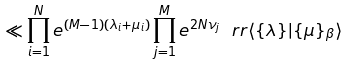<formula> <loc_0><loc_0><loc_500><loc_500>\ll \prod _ { i = 1 } ^ { N } e ^ { ( M - 1 ) ( \lambda _ { i } + \mu _ { i } ) } \prod _ { j = 1 } ^ { M } e ^ { 2 N \nu _ { j } } \ r r \langle \{ \lambda \} | \{ \mu \} _ { \beta } \rangle</formula> 